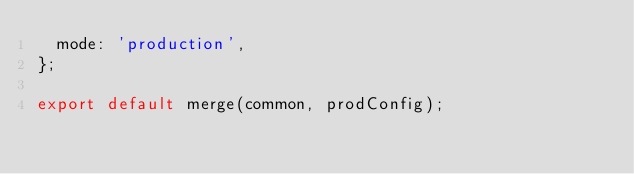Convert code to text. <code><loc_0><loc_0><loc_500><loc_500><_JavaScript_>  mode: 'production',
};

export default merge(common, prodConfig);
</code> 